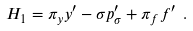<formula> <loc_0><loc_0><loc_500><loc_500>H _ { 1 } = \pi _ { y } y ^ { \prime } - \sigma p _ { \sigma } ^ { \prime } + \pi _ { f } f ^ { \prime } \ .</formula> 